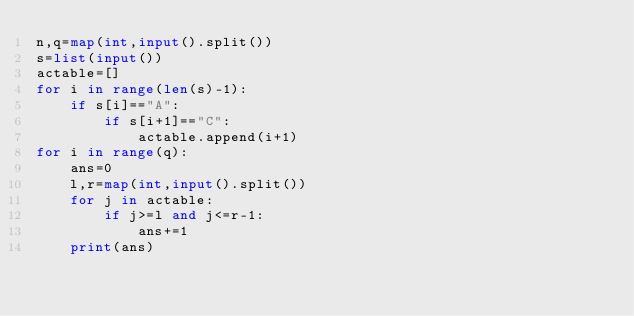Convert code to text. <code><loc_0><loc_0><loc_500><loc_500><_Python_>n,q=map(int,input().split())
s=list(input())
actable=[]
for i in range(len(s)-1):
    if s[i]=="A":
        if s[i+1]=="C":
            actable.append(i+1)
for i in range(q):
    ans=0
    l,r=map(int,input().split())
    for j in actable:
        if j>=l and j<=r-1:
            ans+=1
    print(ans)</code> 